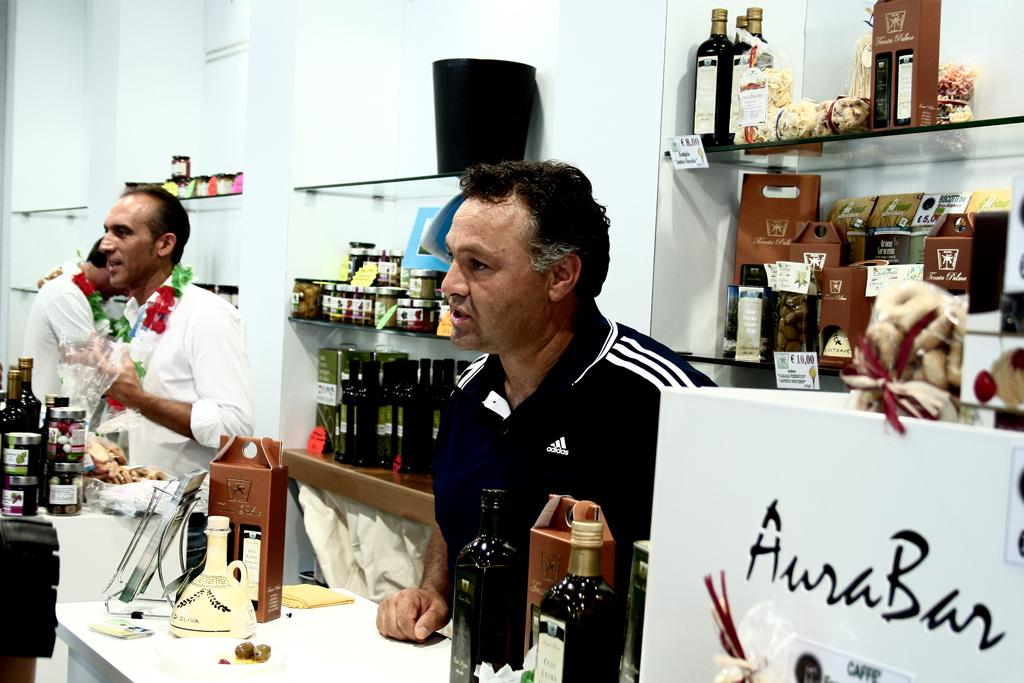<image>
Share a concise interpretation of the image provided. Men stand behind a counter at Aura Bar selling olive oil. 